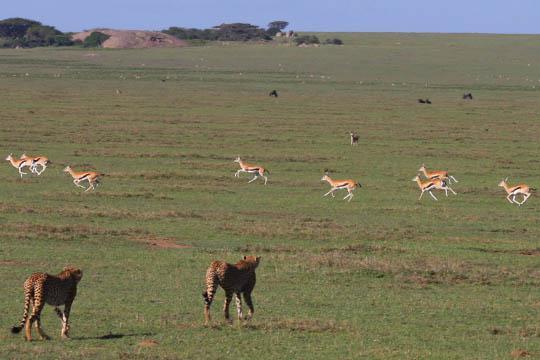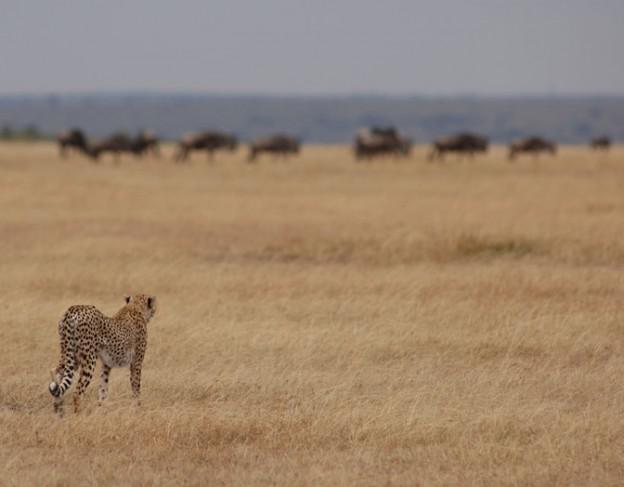The first image is the image on the left, the second image is the image on the right. Given the left and right images, does the statement "One of the cheetahs is touching its prey." hold true? Answer yes or no. No. The first image is the image on the left, the second image is the image on the right. For the images displayed, is the sentence "The sky is visible in the background of at least one of the images." factually correct? Answer yes or no. Yes. 